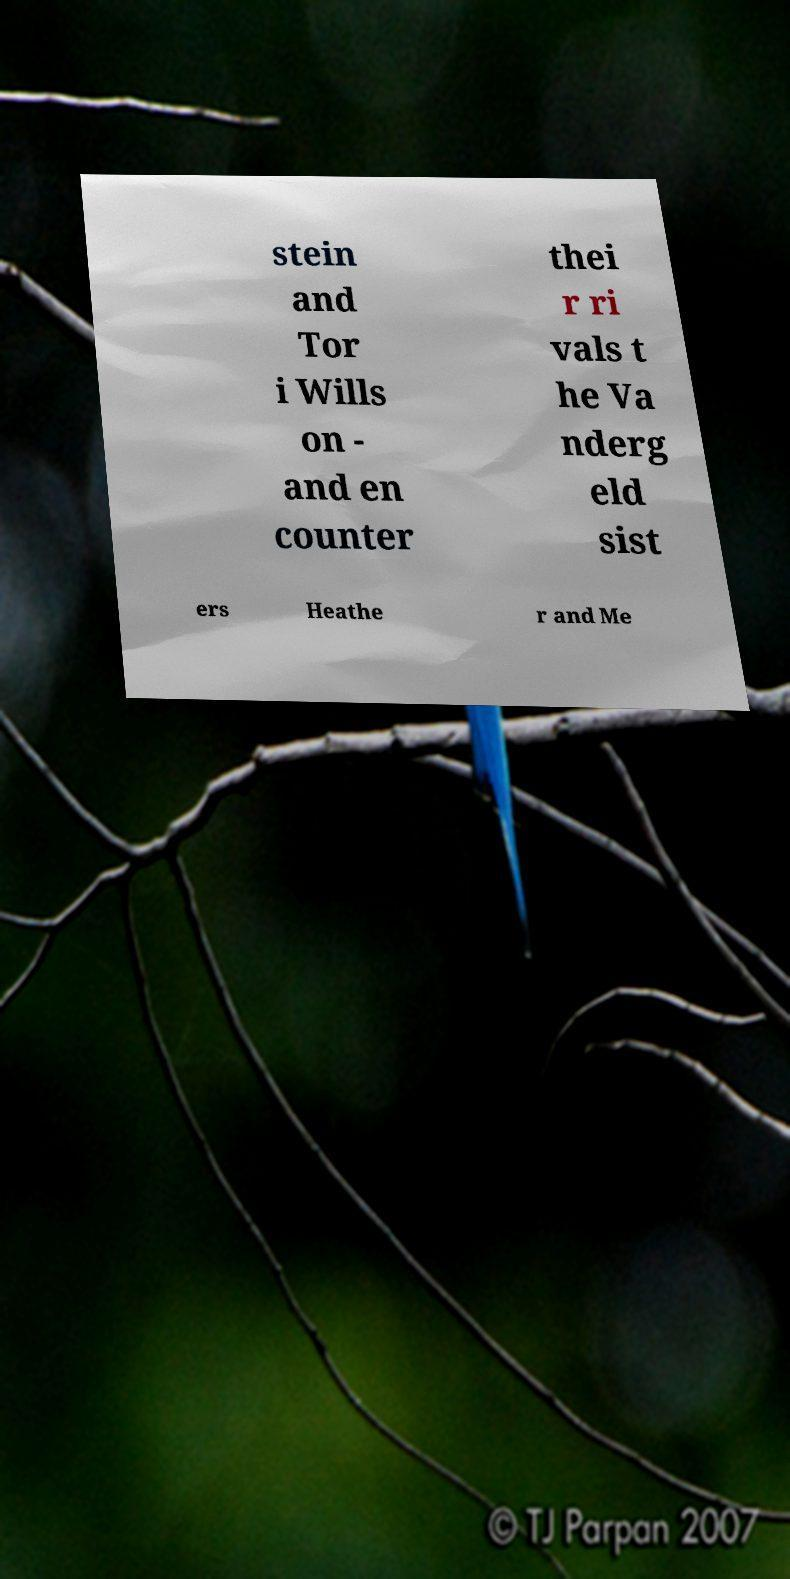There's text embedded in this image that I need extracted. Can you transcribe it verbatim? stein and Tor i Wills on - and en counter thei r ri vals t he Va nderg eld sist ers Heathe r and Me 